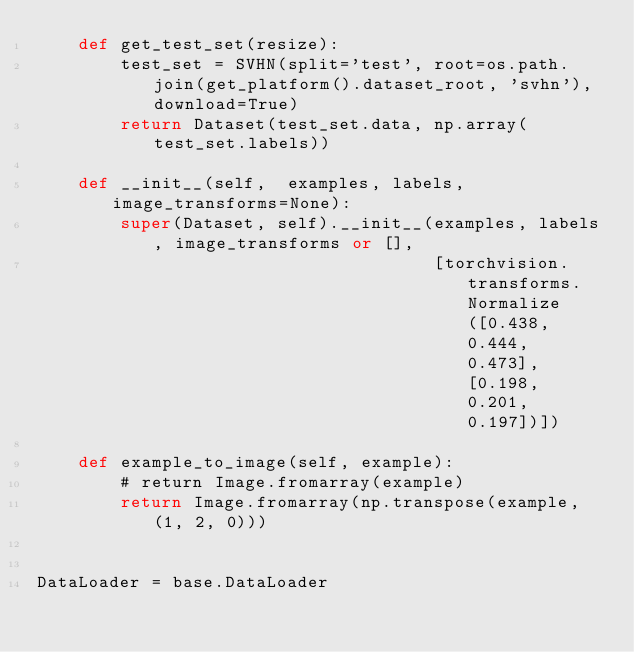Convert code to text. <code><loc_0><loc_0><loc_500><loc_500><_Python_>    def get_test_set(resize):
        test_set = SVHN(split='test', root=os.path.join(get_platform().dataset_root, 'svhn'), download=True)
        return Dataset(test_set.data, np.array(test_set.labels))

    def __init__(self,  examples, labels, image_transforms=None):
        super(Dataset, self).__init__(examples, labels, image_transforms or [],
                                      [torchvision.transforms.Normalize([0.438, 0.444, 0.473], [0.198, 0.201, 0.197])])

    def example_to_image(self, example):
        # return Image.fromarray(example)
        return Image.fromarray(np.transpose(example, (1, 2, 0)))


DataLoader = base.DataLoader
</code> 